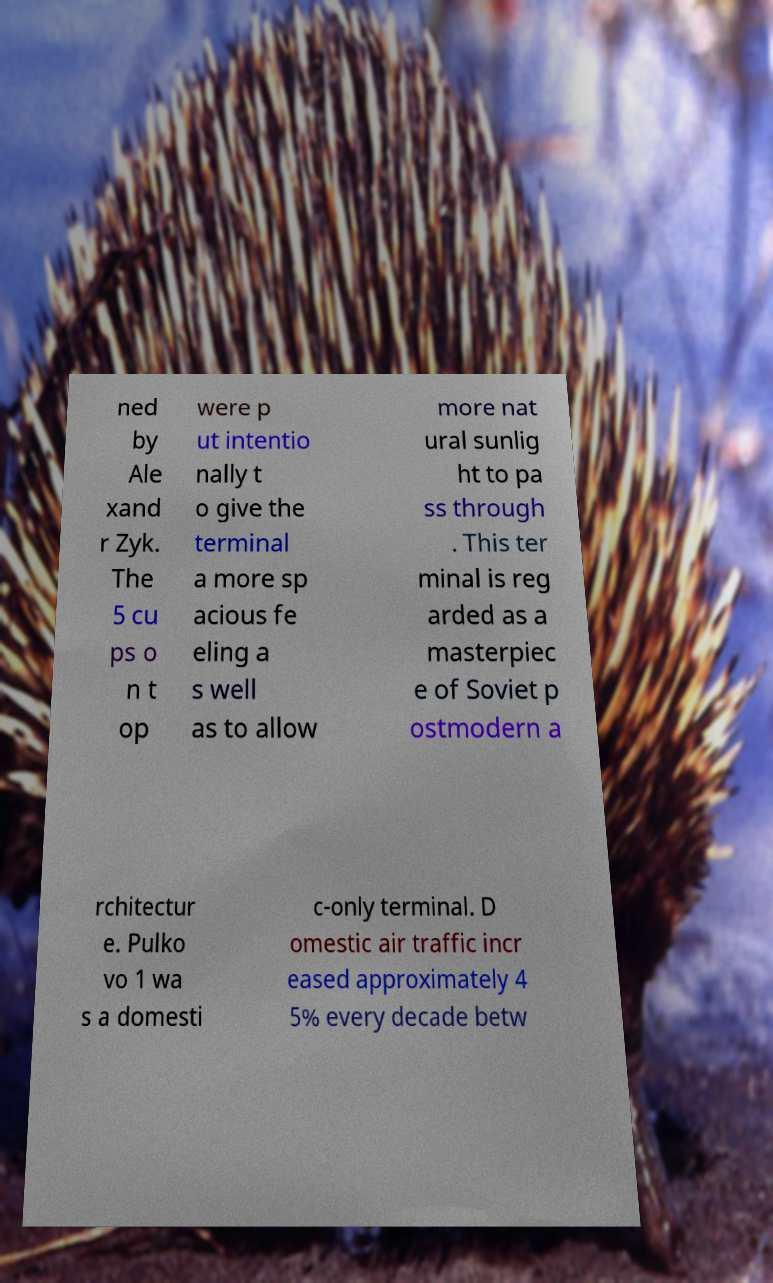Please read and relay the text visible in this image. What does it say? ned by Ale xand r Zyk. The 5 cu ps o n t op were p ut intentio nally t o give the terminal a more sp acious fe eling a s well as to allow more nat ural sunlig ht to pa ss through . This ter minal is reg arded as a masterpiec e of Soviet p ostmodern a rchitectur e. Pulko vo 1 wa s a domesti c-only terminal. D omestic air traffic incr eased approximately 4 5% every decade betw 